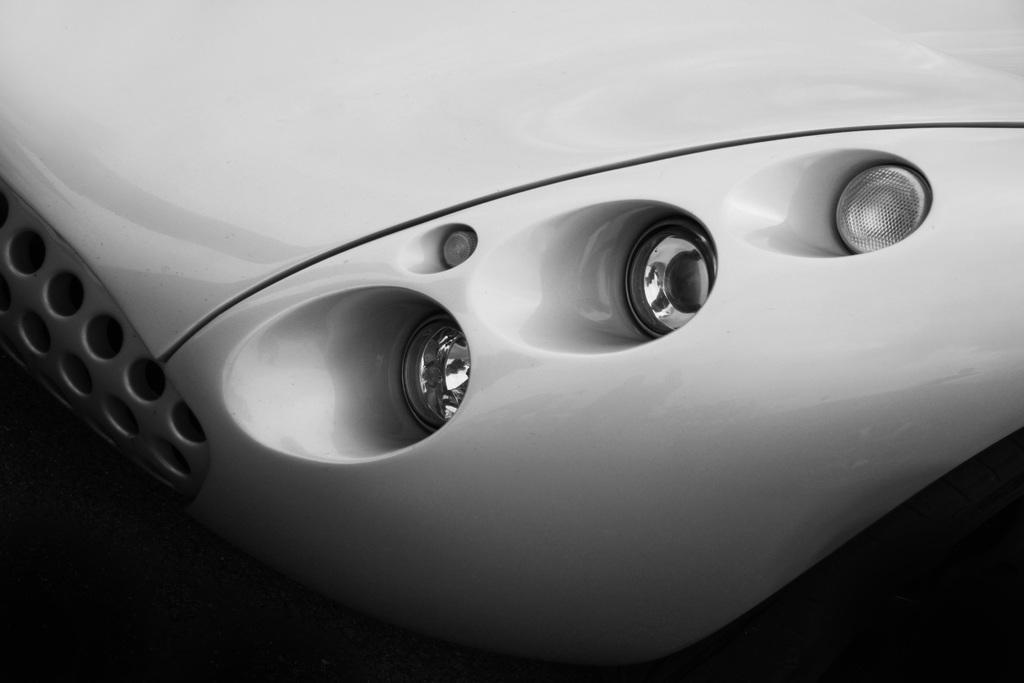What is the color scheme of the image? The image is black and white. What is the main subject of the image? The image is a front view of a vehicle. What are some features visible on the vehicle? There are lights and bolts visible in the image. Can you see a dog sitting inside the vehicle in the image? There is no dog visible in the image; it only shows a front view of the vehicle. Is there a jail visible in the image? There is no jail present in the image; it only features a vehicle. 